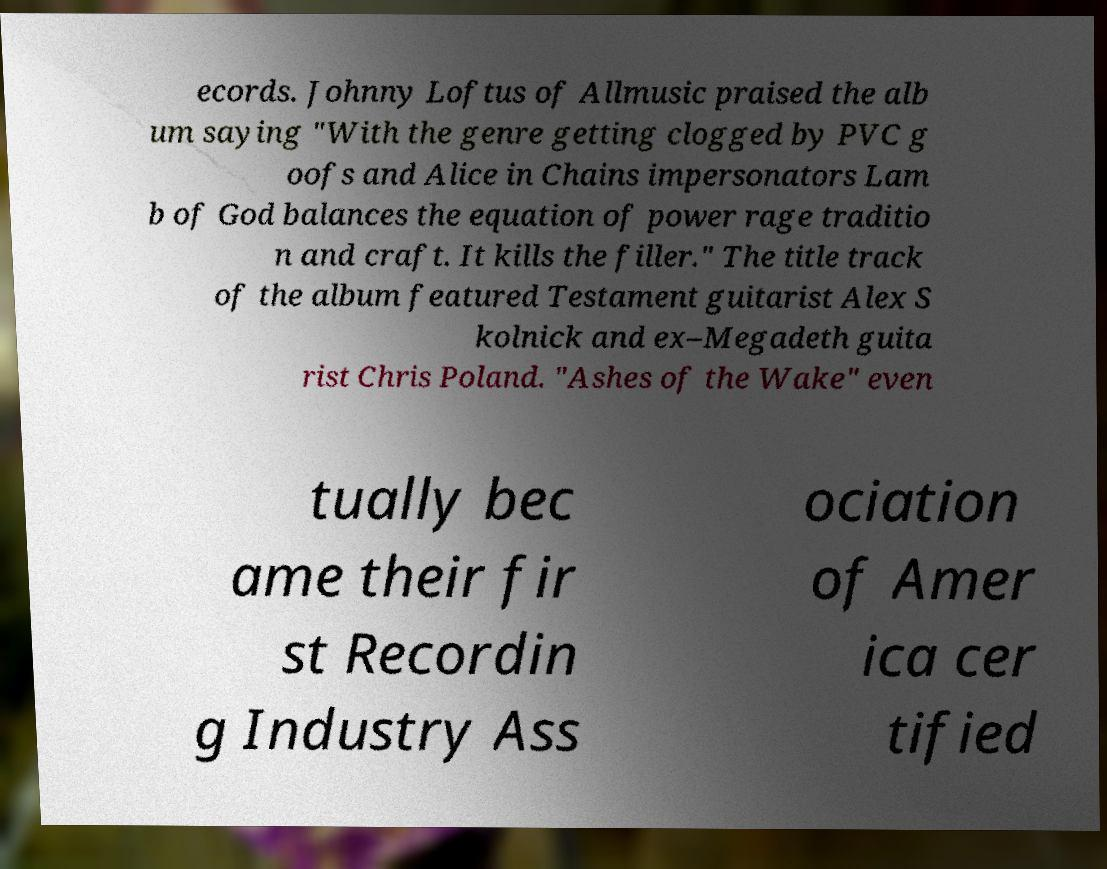Could you assist in decoding the text presented in this image and type it out clearly? ecords. Johnny Loftus of Allmusic praised the alb um saying "With the genre getting clogged by PVC g oofs and Alice in Chains impersonators Lam b of God balances the equation of power rage traditio n and craft. It kills the filler." The title track of the album featured Testament guitarist Alex S kolnick and ex–Megadeth guita rist Chris Poland. "Ashes of the Wake" even tually bec ame their fir st Recordin g Industry Ass ociation of Amer ica cer tified 